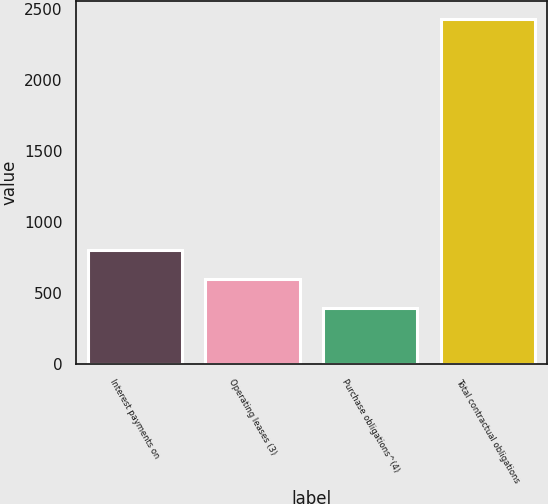<chart> <loc_0><loc_0><loc_500><loc_500><bar_chart><fcel>Interest payments on<fcel>Operating leases (3)<fcel>Purchase obligations^(4)<fcel>Total contractual obligations<nl><fcel>802.6<fcel>598.8<fcel>395<fcel>2433<nl></chart> 